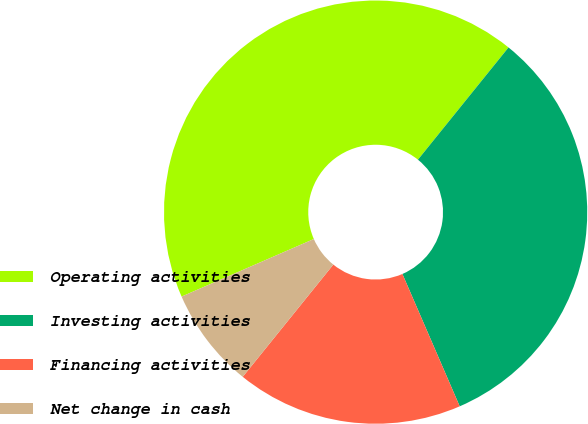<chart> <loc_0><loc_0><loc_500><loc_500><pie_chart><fcel>Operating activities<fcel>Investing activities<fcel>Financing activities<fcel>Net change in cash<nl><fcel>42.34%<fcel>32.69%<fcel>17.31%<fcel>7.66%<nl></chart> 